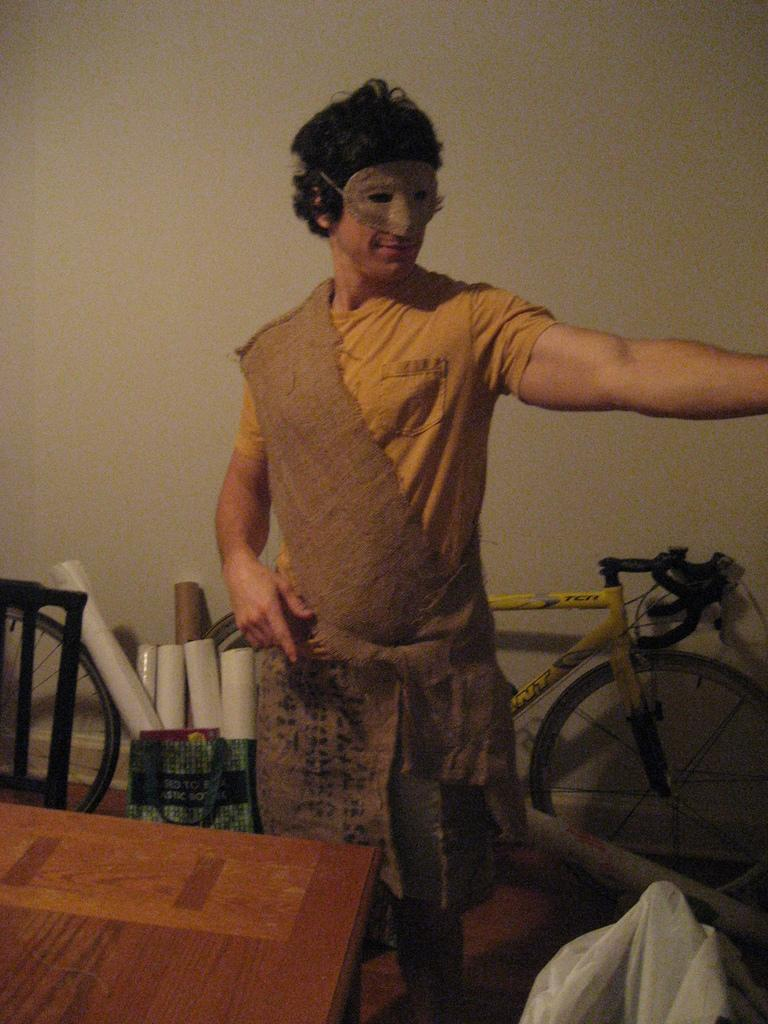What is the main subject of the image? There is a person standing in the image. What is in front of the person? There is a table in front of the person. What is behind the person? There is a bicycle behind the person. What is behind the bicycle? There is a bag with charts behind the bicycle. What is visible behind the bag with charts? There is a wall visible behind the bicycle. What type of disease is the person talking about in the image? There is no indication in the image that the person is talking about any disease. Can you see a robin perched on the person's shoulder in the image? No, there is no robin present in the image. 